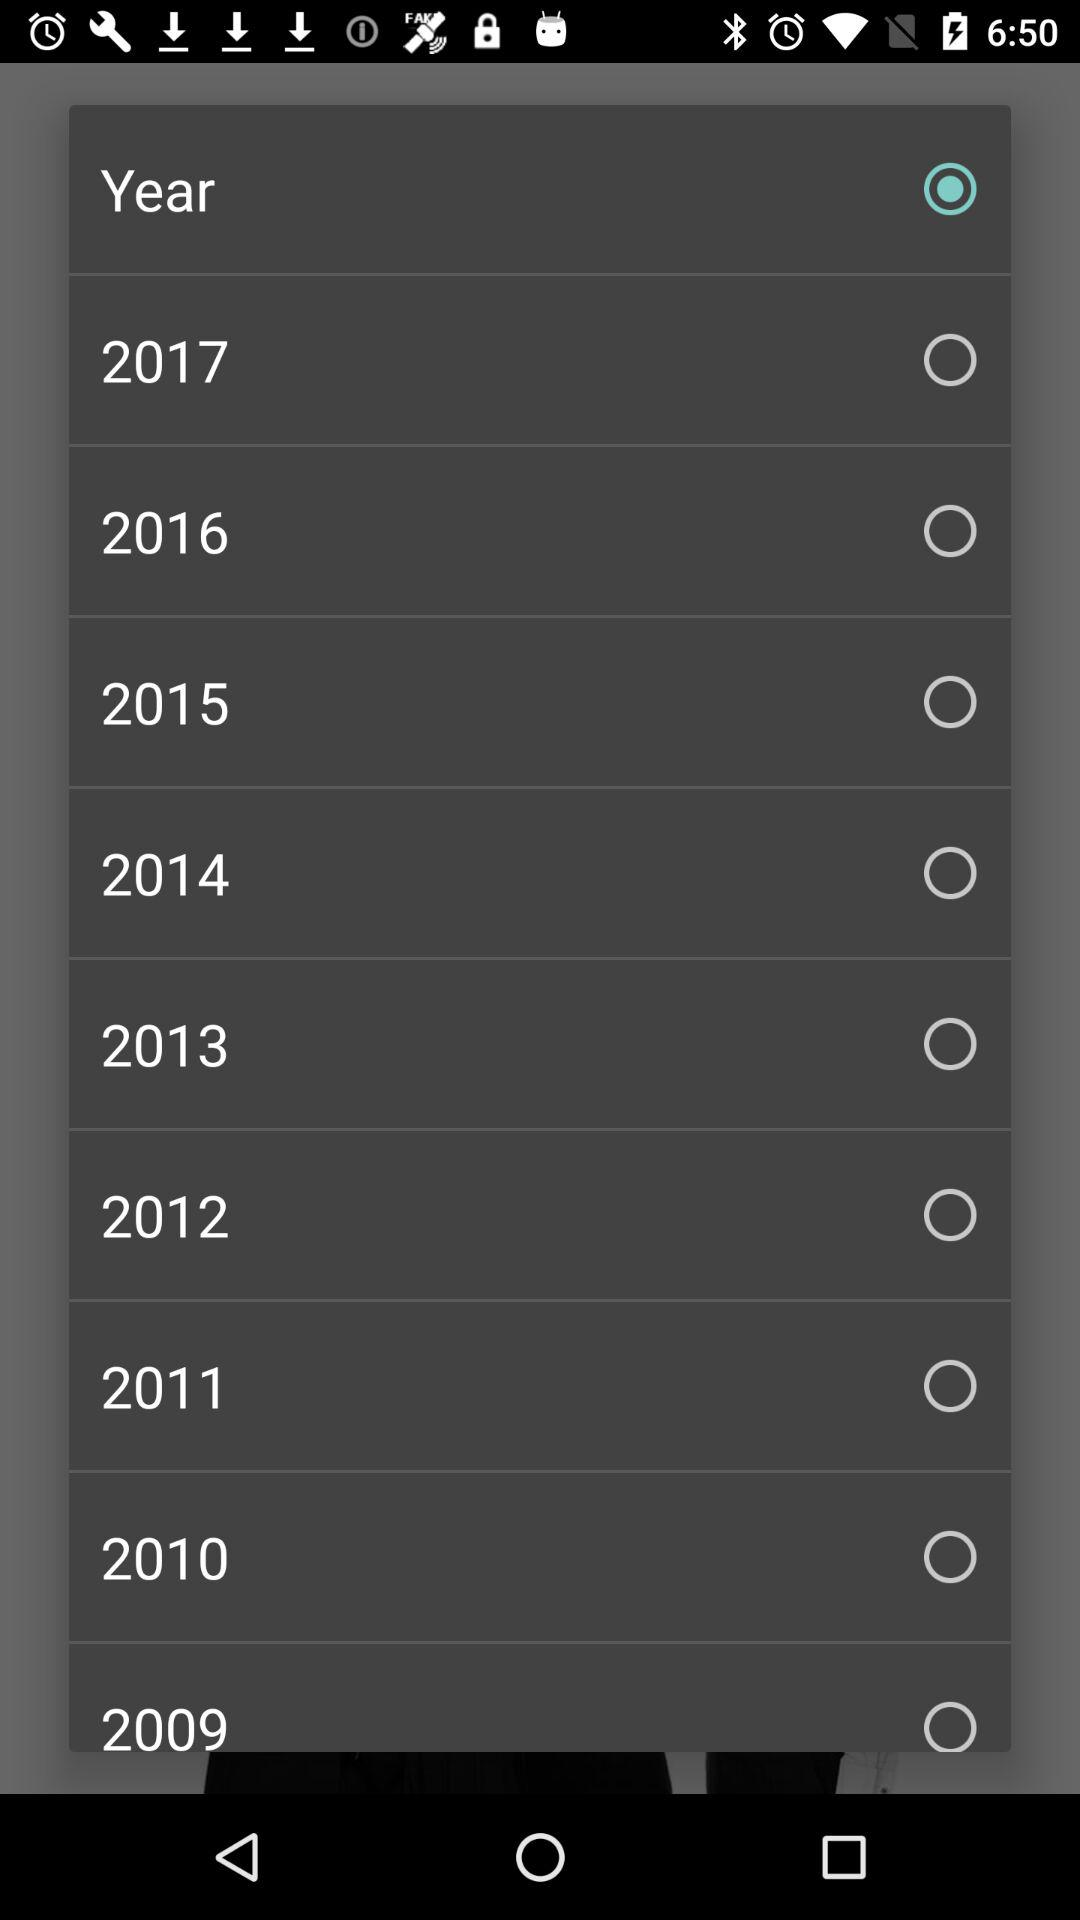What are the available options? The available options are "Year", "2017", "2016", "2015", "2014", "2013", "2012", "2011", "2010" and "2009". 